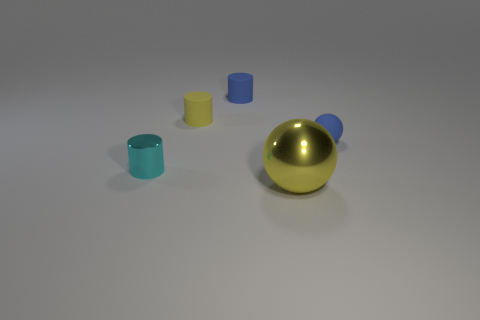Subtract all blue rubber cylinders. How many cylinders are left? 2 Add 1 cylinders. How many objects exist? 6 Subtract all blue cylinders. How many cylinders are left? 2 Subtract all spheres. How many objects are left? 3 Add 4 purple rubber objects. How many purple rubber objects exist? 4 Subtract 0 red spheres. How many objects are left? 5 Subtract all green spheres. Subtract all cyan cubes. How many spheres are left? 2 Subtract all yellow metallic spheres. Subtract all cylinders. How many objects are left? 1 Add 1 tiny rubber spheres. How many tiny rubber spheres are left? 2 